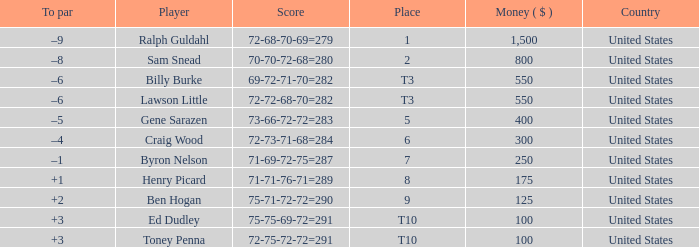Which country has a prize smaller than $250 and the player Henry Picard? United States. 